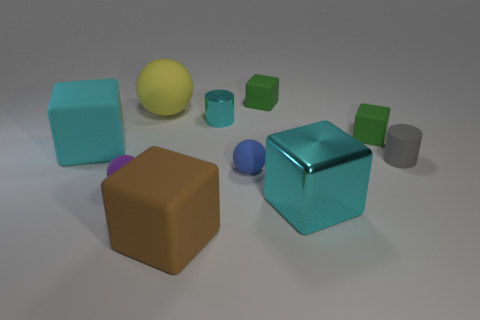Subtract all brown cubes. How many cubes are left? 4 Subtract all big metallic cubes. How many cubes are left? 4 Subtract all blue cubes. Subtract all cyan cylinders. How many cubes are left? 5 Subtract all cylinders. How many objects are left? 8 Subtract all rubber spheres. Subtract all large cyan matte cubes. How many objects are left? 6 Add 7 small cyan objects. How many small cyan objects are left? 8 Add 3 yellow rubber spheres. How many yellow rubber spheres exist? 4 Subtract 0 yellow cubes. How many objects are left? 10 